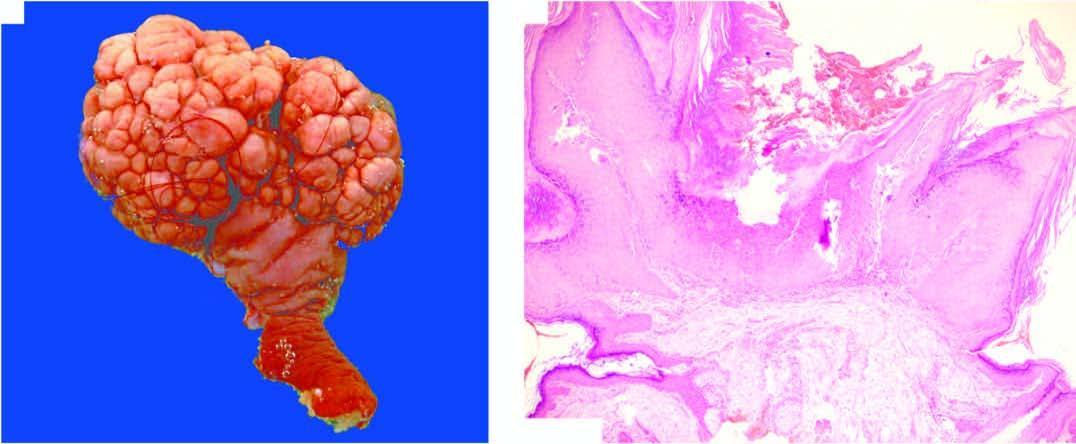what is smooth?
Answer the question using a single word or phrase. Surface 